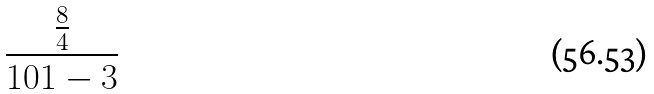<formula> <loc_0><loc_0><loc_500><loc_500>\frac { \frac { 8 } { 4 } } { 1 0 1 - 3 }</formula> 